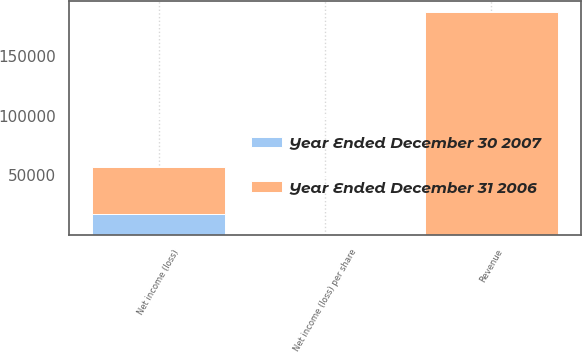Convert chart to OTSL. <chart><loc_0><loc_0><loc_500><loc_500><stacked_bar_chart><ecel><fcel>Revenue<fcel>Net income (loss)<fcel>Net income (loss) per share<nl><fcel>Year Ended December 30 2007<fcel>0.68<fcel>17388<fcel>0.29<nl><fcel>Year Ended December 31 2006<fcel>187103<fcel>38957<fcel>0.68<nl></chart> 